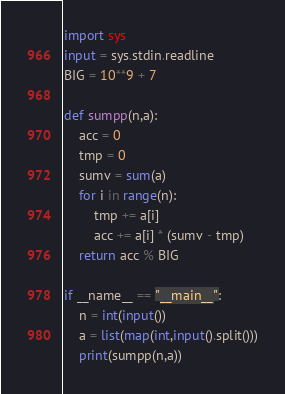<code> <loc_0><loc_0><loc_500><loc_500><_Python_>import sys
input = sys.stdin.readline
BIG = 10**9 + 7

def sumpp(n,a):
    acc = 0
    tmp = 0
    sumv = sum(a)
    for i in range(n):
        tmp += a[i]
        acc += a[i] * (sumv - tmp)
    return acc % BIG

if __name__ == "__main__":
    n = int(input())
    a = list(map(int,input().split()))
    print(sumpp(n,a))
</code> 